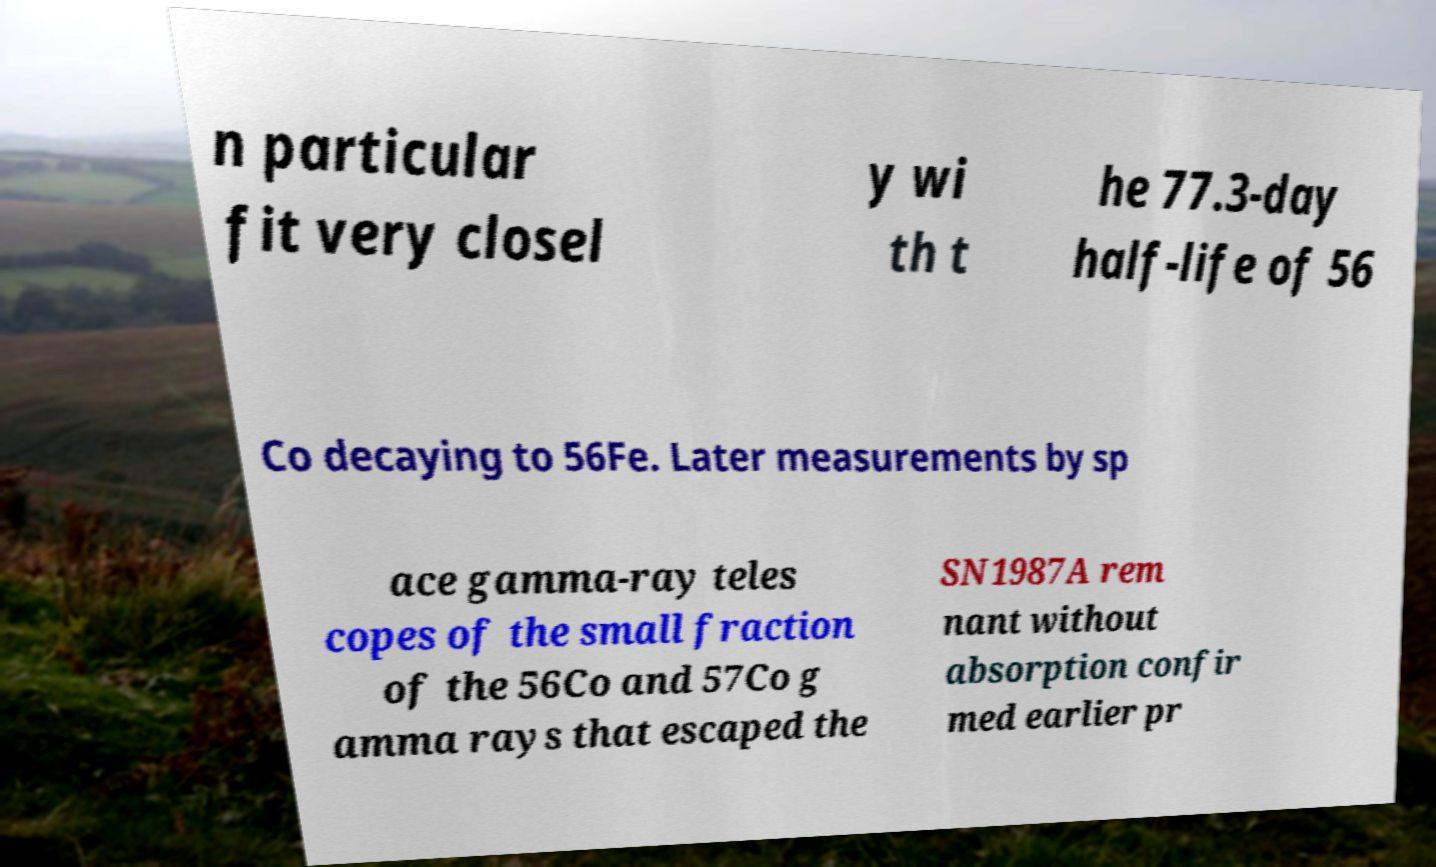There's text embedded in this image that I need extracted. Can you transcribe it verbatim? n particular fit very closel y wi th t he 77.3-day half-life of 56 Co decaying to 56Fe. Later measurements by sp ace gamma-ray teles copes of the small fraction of the 56Co and 57Co g amma rays that escaped the SN1987A rem nant without absorption confir med earlier pr 